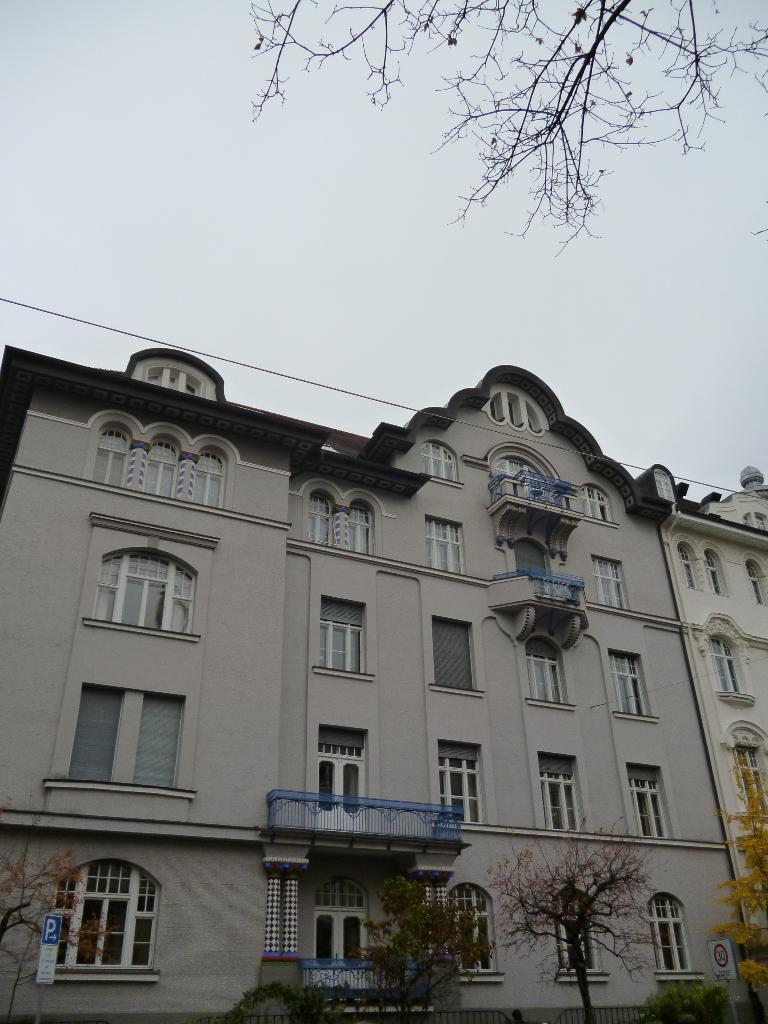What type of natural elements can be seen in the image? There are trees in the image. What man-made structures are present in the image? There are signboards and a building with windows in the image. What can be seen in the background of the image? The sky is visible in the background of the image. What riddle is written on the signboards in the image? There is no riddle present on the signboards in the image; they likely contain text related to directions, advertisements, or other information. How many divisions can be seen in the building in the image? The image does not provide enough detail to determine the number of divisions or floors in the building. 